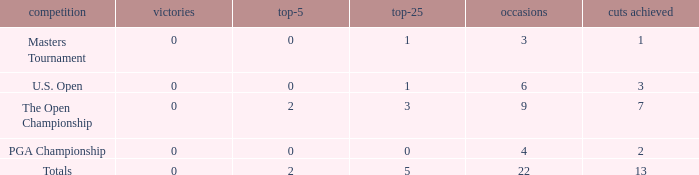What is the total number of wins for events with under 2 top-5s, under 5 top-25s, and more than 4 events played? 1.0. 